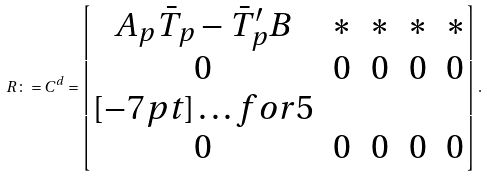<formula> <loc_0><loc_0><loc_500><loc_500>R \colon = C ^ { d } = \begin{bmatrix} A _ { p } \bar { T } _ { p } - \bar { T } ^ { \prime } _ { p } B & * & * & * & * \\ 0 & 0 & 0 & 0 & 0 \\ [ - 7 p t ] \hdots f o r { 5 } \\ 0 & 0 & 0 & 0 & 0 \\ \end{bmatrix} .</formula> 